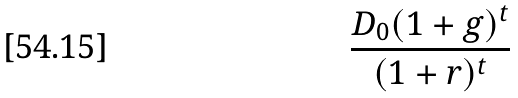Convert formula to latex. <formula><loc_0><loc_0><loc_500><loc_500>\frac { D _ { 0 } ( 1 + g ) ^ { t } } { ( 1 + r ) ^ { t } }</formula> 